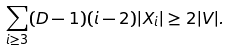<formula> <loc_0><loc_0><loc_500><loc_500>\sum _ { i \geq 3 } ( D - 1 ) ( i - 2 ) | X _ { i } | \geq 2 | V | .</formula> 